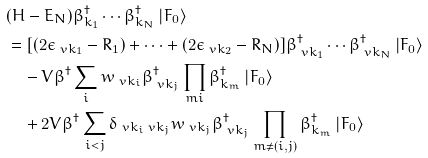<formula> <loc_0><loc_0><loc_500><loc_500>& ( H - E _ { N } ) \beta ^ { \dagger } _ { k _ { 1 } } \cdots \beta ^ { \dagger } _ { k _ { N } } \left | F _ { 0 } \right > \\ & = [ ( 2 \epsilon _ { \ v k _ { 1 } } - R _ { 1 } ) + \cdots + ( 2 \epsilon _ { \ v k _ { 2 } } - R _ { N } ) ] \beta ^ { \dagger } _ { \ v k _ { 1 } } \cdots \beta ^ { \dagger } _ { \ v k _ { N } } \left | F _ { 0 } \right > \\ & \quad - V \beta ^ { \dagger } \sum _ { i } w _ { \ v k _ { i } } \beta ^ { \dagger } _ { \ v k _ { j } } \prod _ { m i } \beta ^ { \dagger } _ { k _ { m } } \left | F _ { 0 } \right > \\ & \quad + 2 V \beta ^ { \dagger } \sum _ { i < j } \delta _ { \ v k _ { i } \ v k _ { j } } w _ { \ v k _ { j } } \beta ^ { \dagger } _ { \ v k _ { j } } \prod _ { m \neq ( i , j ) } \beta ^ { \dagger } _ { k _ { m } } \left | F _ { 0 } \right ></formula> 